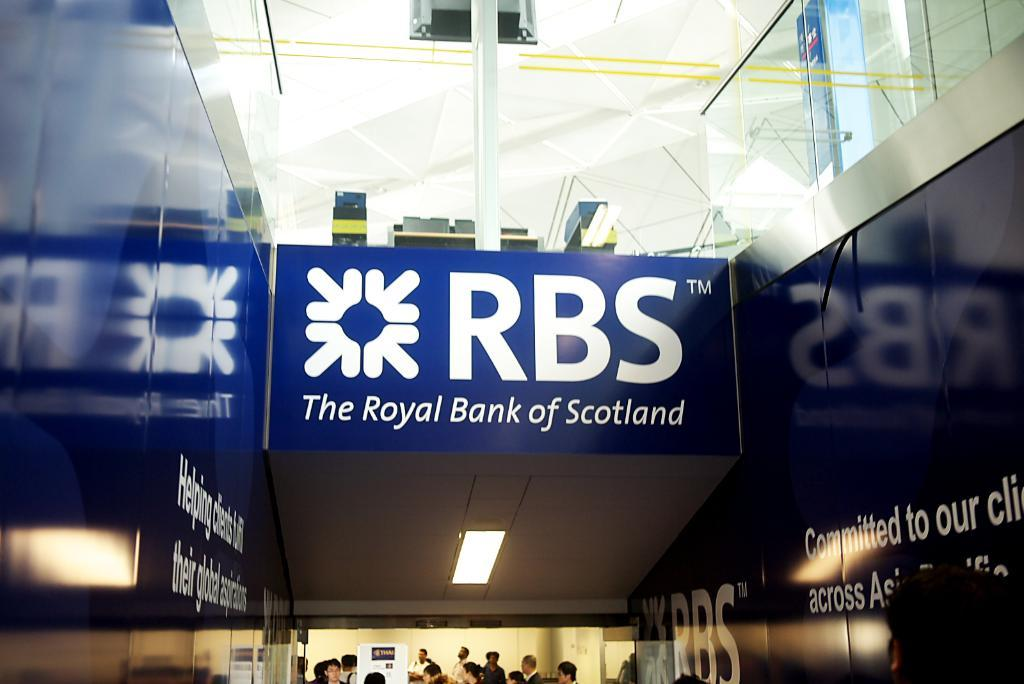Where was the image taken? The image was taken inside a building. What can be seen at the bottom of the image? There are people at the bottom of the image. What objects are on a table at the top of the image? There are laptops on a table at the top of the image. What type of lighting is present in the image? Ceiling lights are visible in the image. How many islands can be seen in the image? There are no islands present in the image; it was taken inside a building. What type of chair is visible in the image? There is no chair visible in the image. 